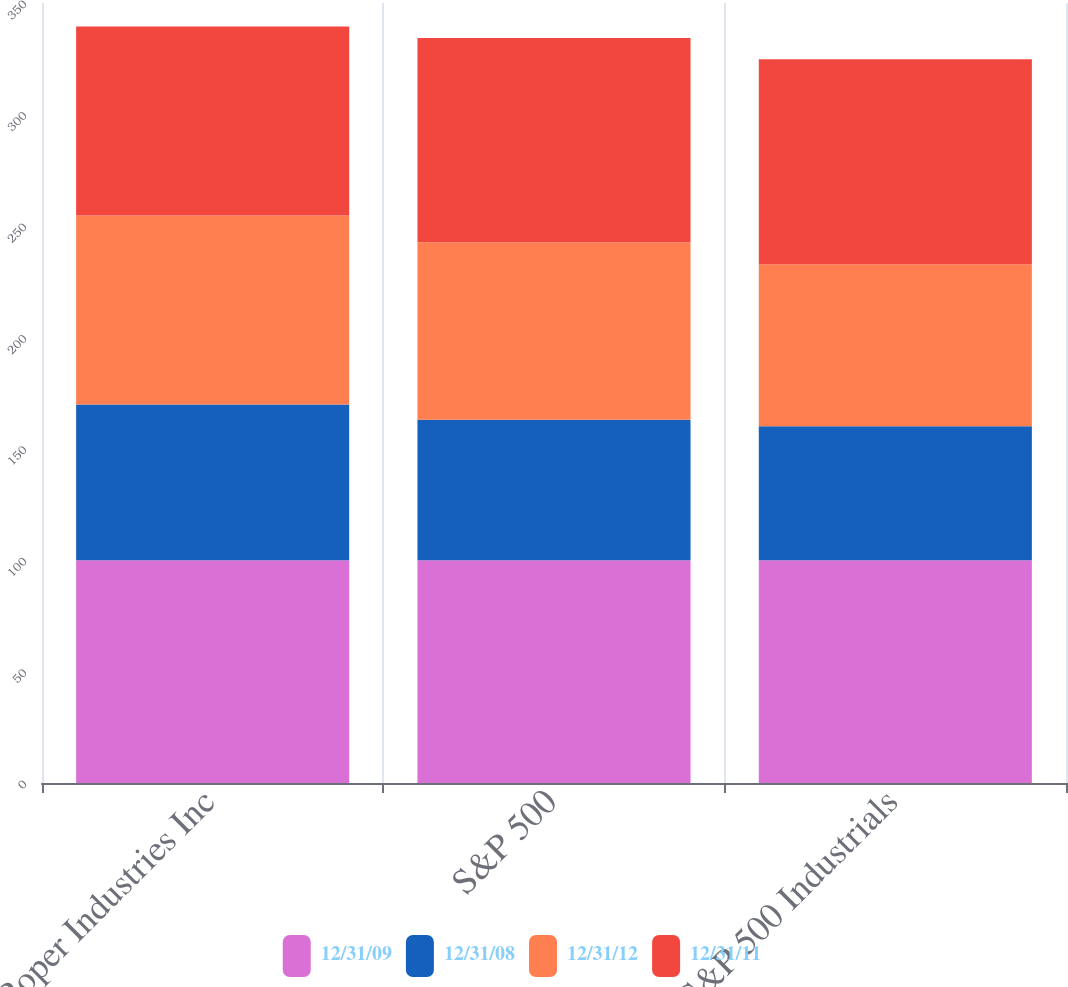Convert chart to OTSL. <chart><loc_0><loc_0><loc_500><loc_500><stacked_bar_chart><ecel><fcel>Roper Industries Inc<fcel>S&P 500<fcel>S&P 500 Industrials<nl><fcel>12/31/09<fcel>100<fcel>100<fcel>100<nl><fcel>12/31/08<fcel>69.79<fcel>63<fcel>60.08<nl><fcel>12/31/12<fcel>84.83<fcel>79.67<fcel>72.65<nl><fcel>12/31/11<fcel>84.83<fcel>91.67<fcel>92.07<nl></chart> 